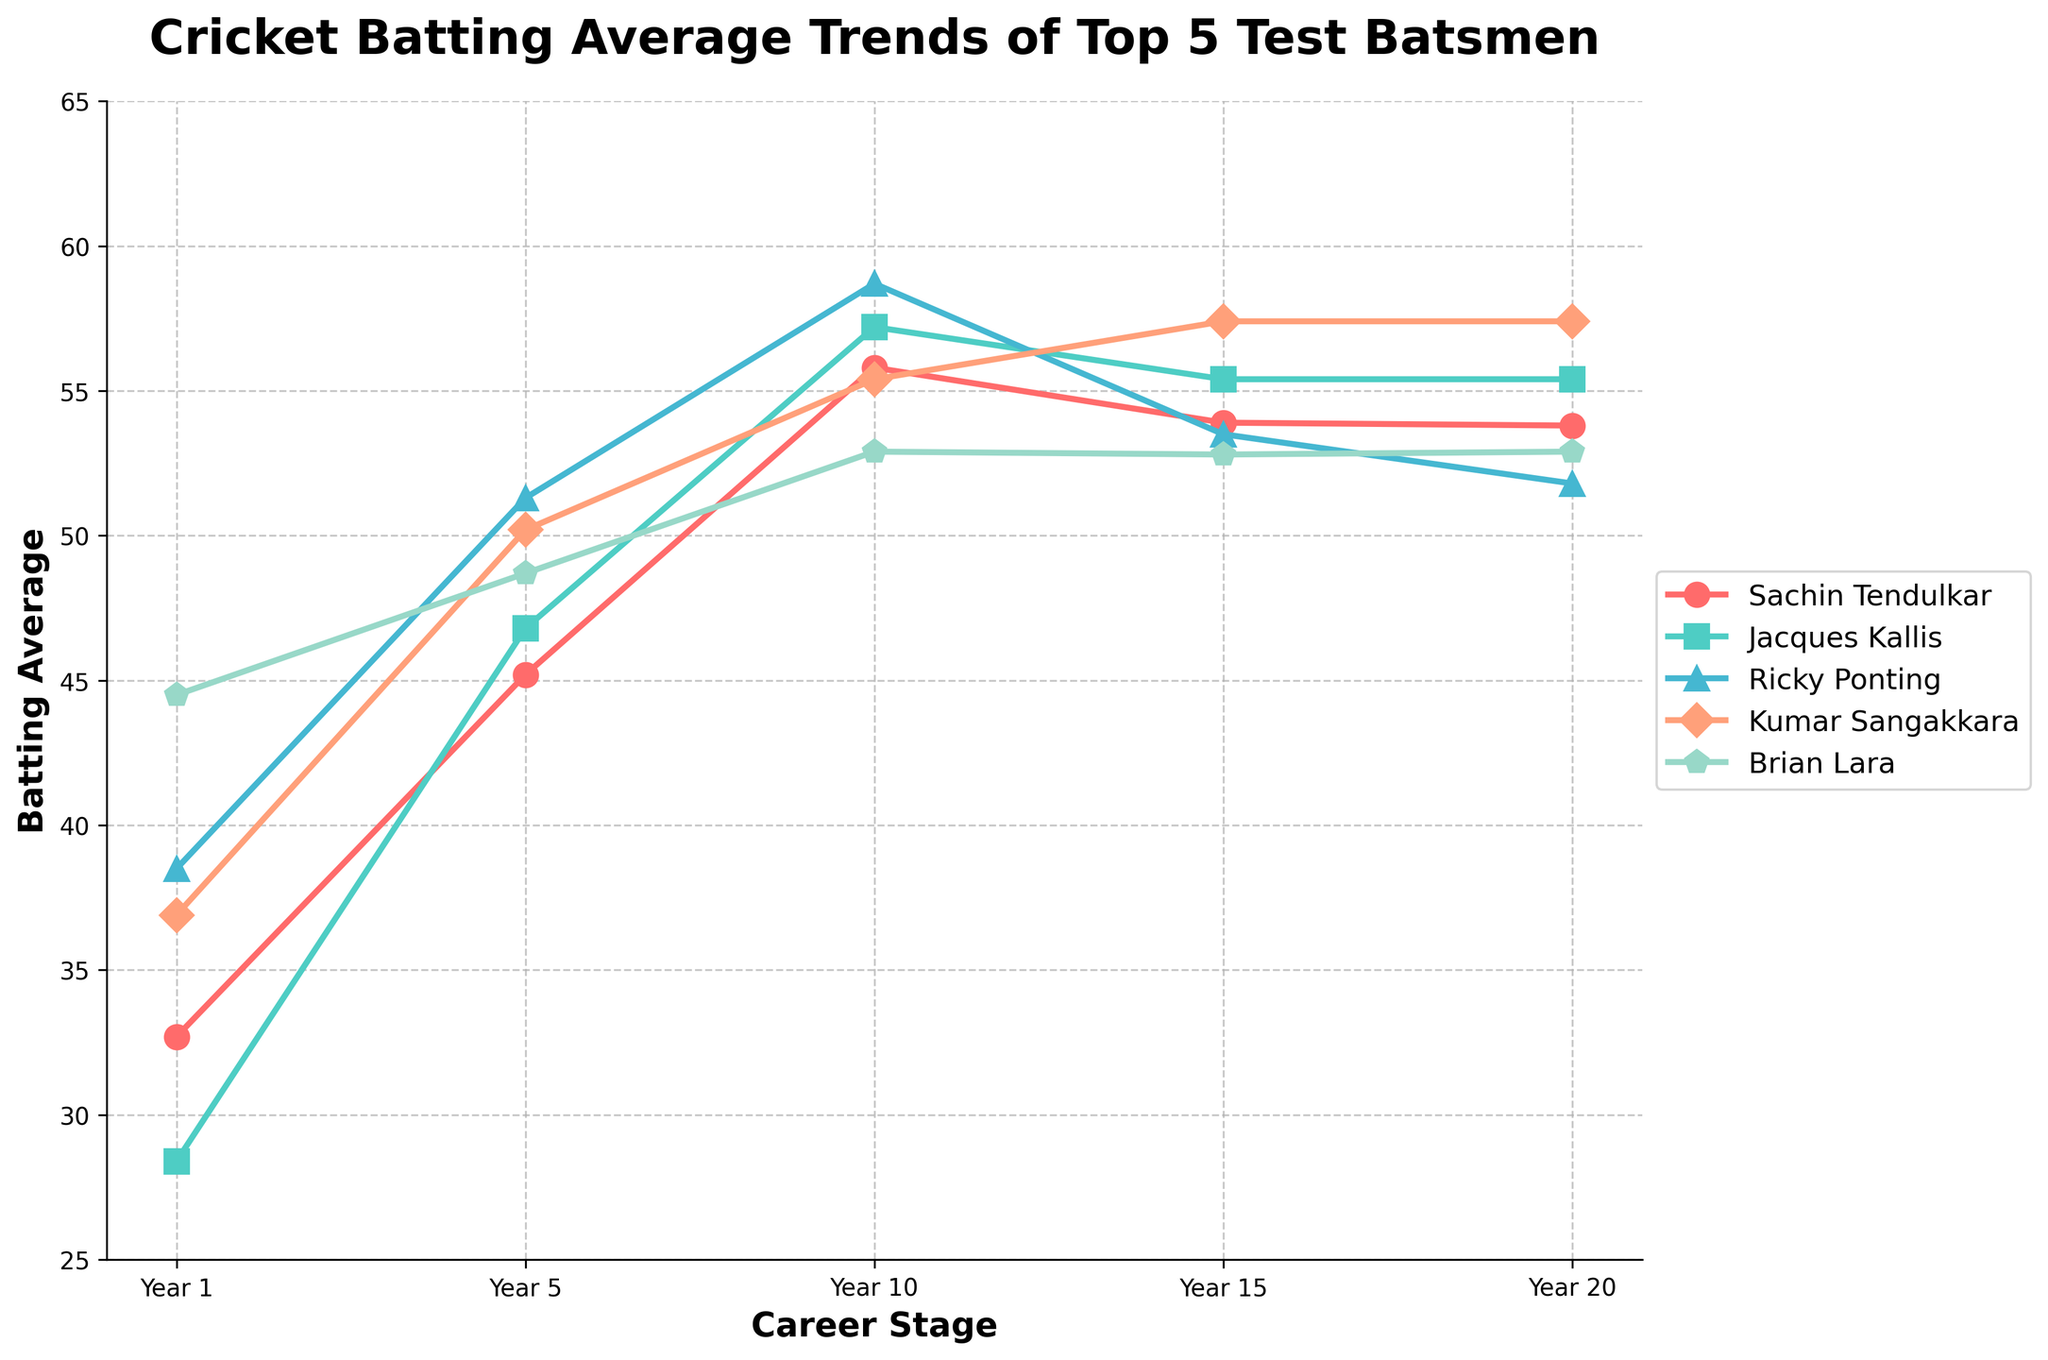What's the average batting average of Sachin Tendulkar over his career stages? The batting averages of Sachin Tendulkar over different career stages are 32.7, 45.2, 55.8, 53.9, and 53.8. Summing these values gives 241.4. Dividing by 5 (the number of stages) gives 241.4 / 5 = 48.28
Answer: 48.28 Which player has the highest batting average in Year 10? In the Year 10 column, the batting averages for the players are 55.8 (Sachin Tendulkar), 57.2 (Jacques Kallis), 58.7 (Ricky Ponting), 55.4 (Kumar Sangakkara), and 52.9 (Brian Lara). The highest value among these is 58.7 by Ricky Ponting
Answer: Ricky Ponting By how much did Jacques Kallis's batting average increase from Year 1 to Year 5? Jacques Kallis's batting average in Year 1 is 28.4, and in Year 5 it is 46.8. The increase is calculated as 46.8 - 28.4 = 18.4
Answer: 18.4 Which player's batting average remained the same from Year 15 to Year 20? By looking at the figures, Kumar Sangakkara's and Jacques Kallis's batting averages are the same in Year 15 and Year 20, with both maintaining 57.4 and 55.4 respectively
Answer: Kumar Sangakkara and Jacques Kallis What's the difference between the highest and lowest batting averages in Year 1? The Year 1 batting averages are 32.7 (Sachin Tendulkar), 28.4 (Jacques Kallis), 38.5 (Ricky Ponting), 36.9 (Kumar Sangakkara), and 44.5 (Brian Lara). The highest value here is 44.5 (Brian Lara) and the lowest is 28.4 (Jacques Kallis). The difference is 44.5 - 28.4 = 16.1
Answer: 16.1 Which player shows a decrease in batting average from Year 10 to Year 15? By examining the trends, Ricky Ponting’s batting average decreases from Year 10 (58.7) to Year 15 (53.5)
Answer: Ricky Ponting Who has the most stable batting averages over the 20 years (smallest variation)? We calculate the range (difference between highest and lowest values) of each player's averages.
- Sachin Tendulkar: 55.8 - 32.7 = 23.1
- Jacques Kallis: 57.2 - 28.4 = 28.8
- Ricky Ponting: 58.7 - 38.5 = 20.2
- Kumar Sangakkara: 57.4 - 36.9 = 20.5
- Brian Lara: 52.9 - 44.5 = 8.4
Brian Lara has the smallest range, suggesting the most stable averages
Answer: Brian Lara Which player had the highest batting average at the start of their career? In Year 1, the batting averages are 32.7 (Sachin Tendulkar), 28.4 (Jacques Kallis), 38.5 (Ricky Ponting), 36.9 (Kumar Sangakkara), and 44.5 (Brian Lara). The highest average is Brian Lara’s 44.5
Answer: Brian Lara 